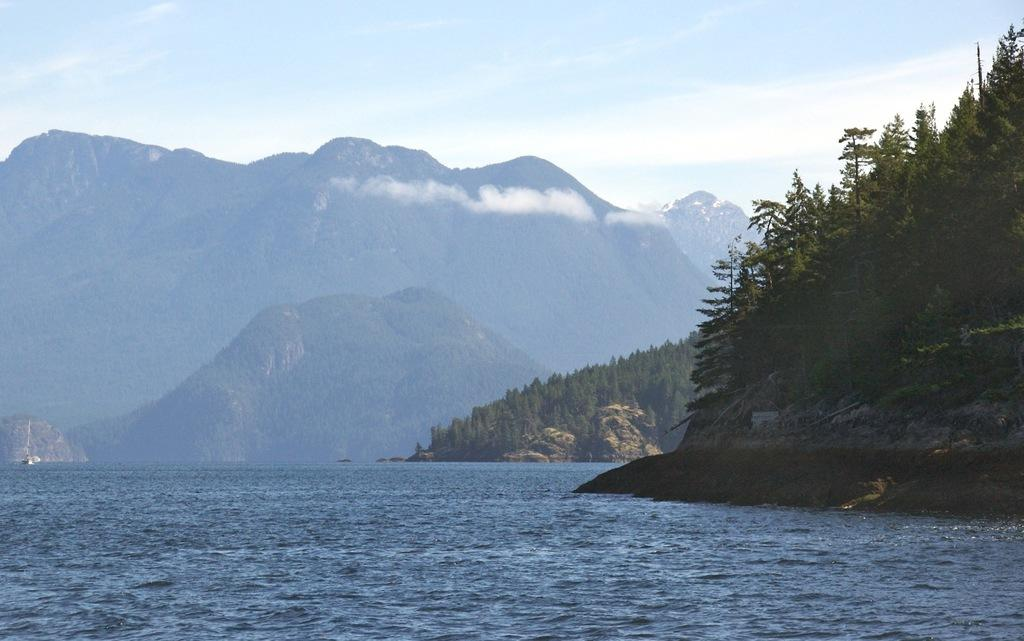What is the main element present in the image? There is water in the image. What type of natural features can be seen in the image? There are trees and mountains in the image. What part of the natural environment is visible in the image? The sky is visible in the image. What type of governor is depicted in the image? There is no governor present in the image; it features natural elements such as water, trees, mountains, and the sky. How many flies can be seen in the image? There are no flies present in the image, as it focuses on natural elements like water, trees, mountains, and the sky. 